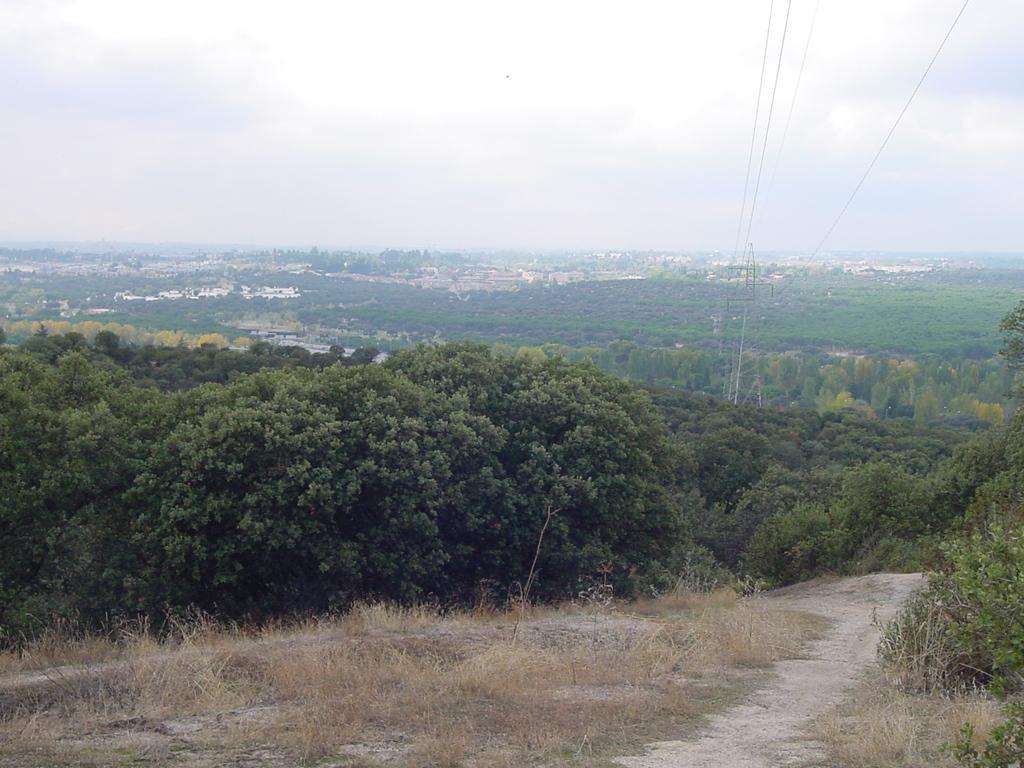Please provide a concise description of this image. This picture shows trees and buildings and we see grass on the ground and a cloudy Sky 